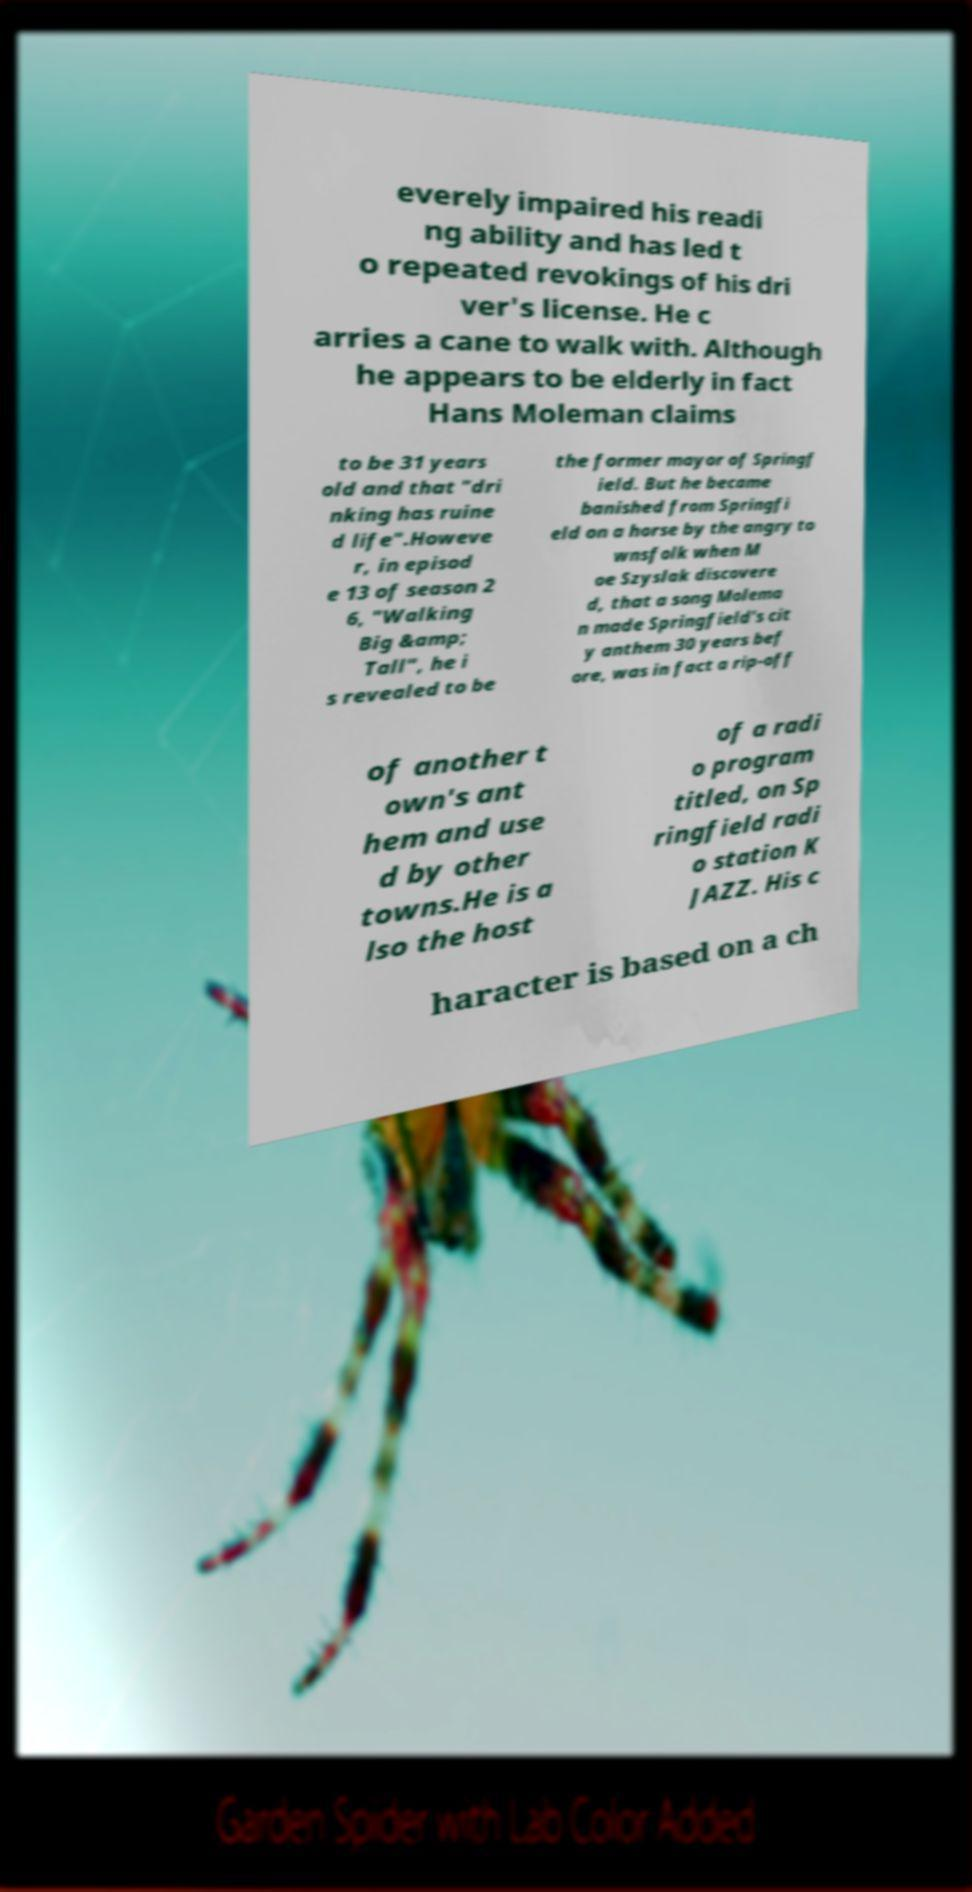Can you accurately transcribe the text from the provided image for me? everely impaired his readi ng ability and has led t o repeated revokings of his dri ver's license. He c arries a cane to walk with. Although he appears to be elderly in fact Hans Moleman claims to be 31 years old and that "dri nking has ruine d life".Howeve r, in episod e 13 of season 2 6, "Walking Big &amp; Tall", he i s revealed to be the former mayor of Springf ield. But he became banished from Springfi eld on a horse by the angry to wnsfolk when M oe Szyslak discovere d, that a song Molema n made Springfield's cit y anthem 30 years bef ore, was in fact a rip-off of another t own's ant hem and use d by other towns.He is a lso the host of a radi o program titled, on Sp ringfield radi o station K JAZZ. His c haracter is based on a ch 